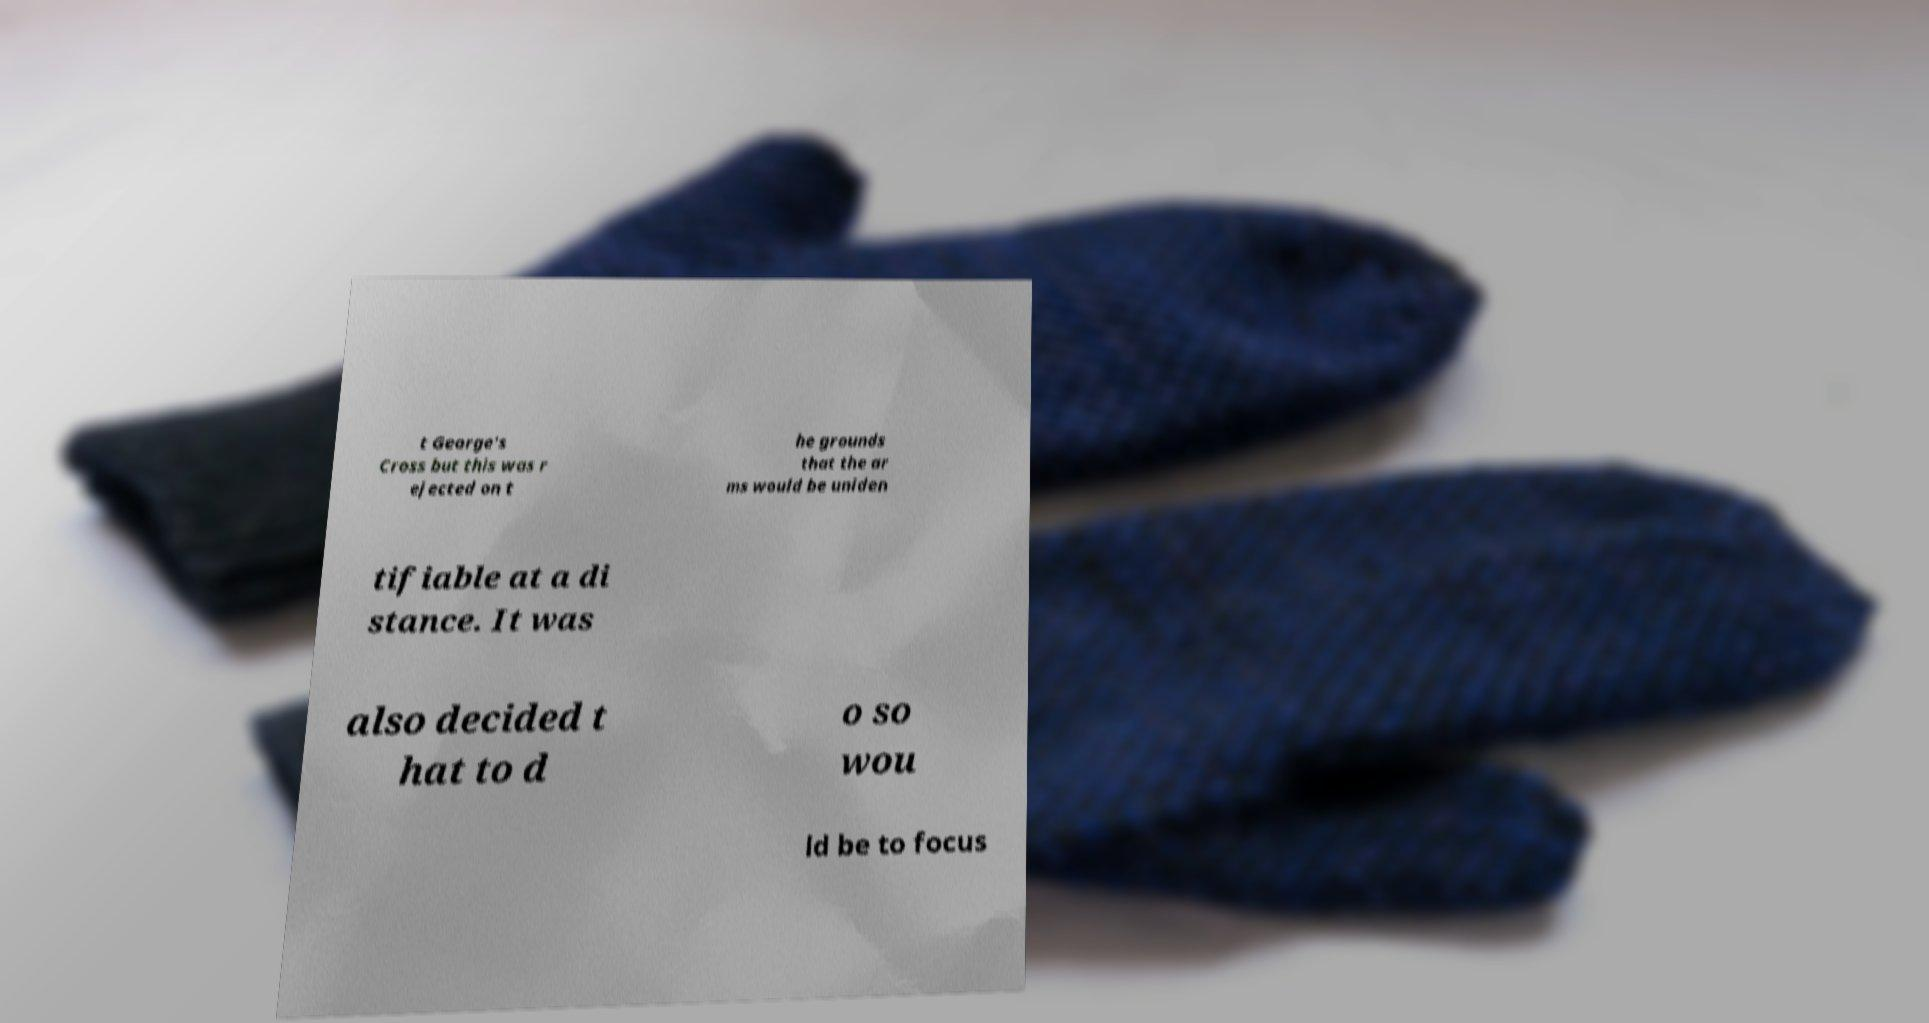Could you extract and type out the text from this image? t George's Cross but this was r ejected on t he grounds that the ar ms would be uniden tifiable at a di stance. It was also decided t hat to d o so wou ld be to focus 